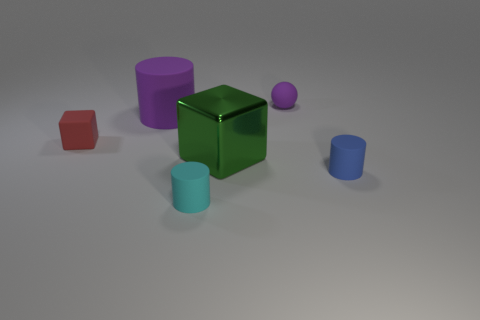Does the large shiny cube have the same color as the small sphere? After examining the image, the large shiny cube is indeed a different color than the small sphere; the cube displays a vibrant green hue, while the sphere is a muted purple. 